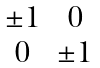Convert formula to latex. <formula><loc_0><loc_0><loc_500><loc_500>\begin{matrix} \pm 1 & 0 \\ 0 & \pm 1 \end{matrix}</formula> 